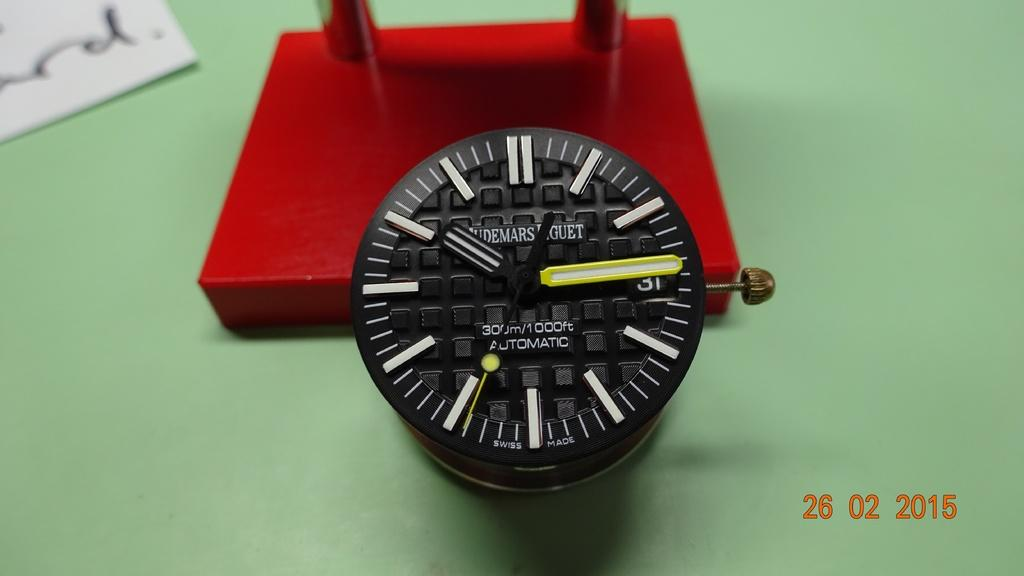<image>
Summarize the visual content of the image. The black watch here is usable up to a 1,000 feet under water 